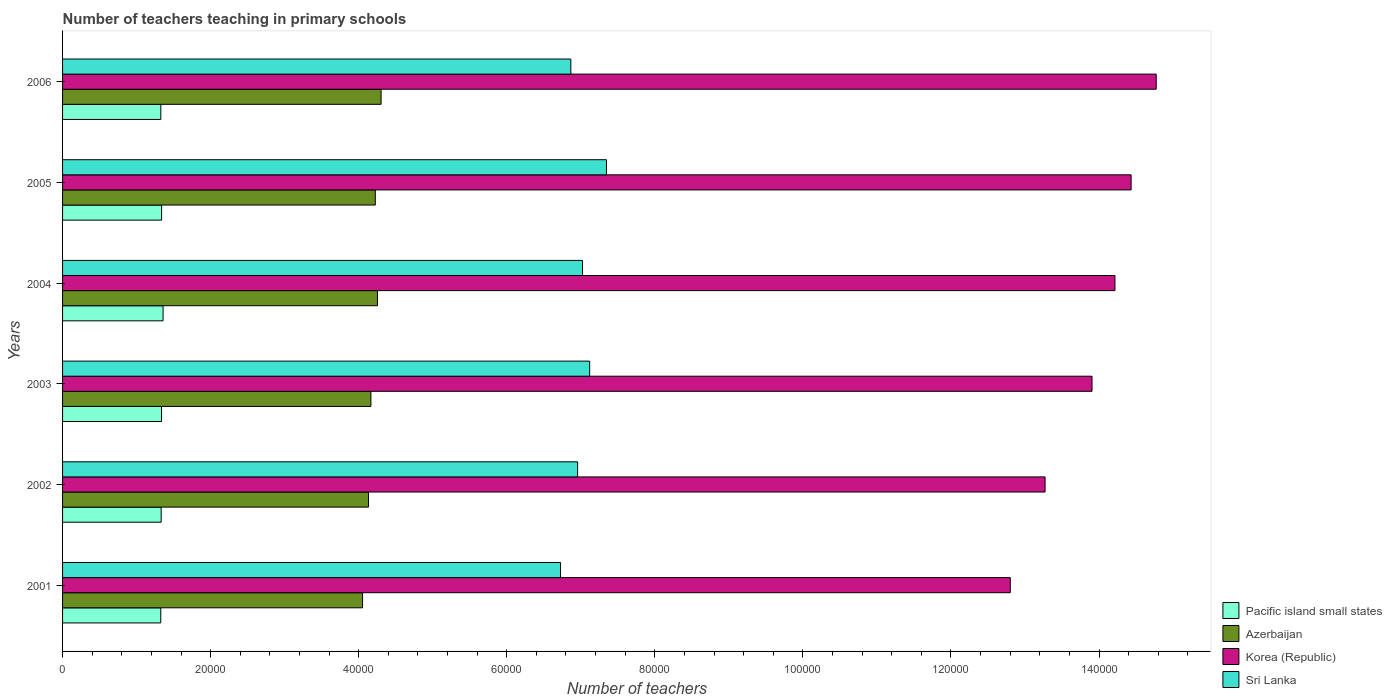Are the number of bars per tick equal to the number of legend labels?
Ensure brevity in your answer.  Yes. How many bars are there on the 1st tick from the top?
Ensure brevity in your answer.  4. What is the number of teachers teaching in primary schools in Korea (Republic) in 2002?
Ensure brevity in your answer.  1.33e+05. Across all years, what is the maximum number of teachers teaching in primary schools in Azerbaijan?
Provide a succinct answer. 4.30e+04. Across all years, what is the minimum number of teachers teaching in primary schools in Sri Lanka?
Offer a terse response. 6.73e+04. In which year was the number of teachers teaching in primary schools in Pacific island small states minimum?
Offer a very short reply. 2001. What is the total number of teachers teaching in primary schools in Pacific island small states in the graph?
Your answer should be compact. 8.02e+04. What is the difference between the number of teachers teaching in primary schools in Azerbaijan in 2005 and that in 2006?
Ensure brevity in your answer.  -783. What is the difference between the number of teachers teaching in primary schools in Pacific island small states in 2005 and the number of teachers teaching in primary schools in Azerbaijan in 2001?
Offer a terse response. -2.71e+04. What is the average number of teachers teaching in primary schools in Korea (Republic) per year?
Keep it short and to the point. 1.39e+05. In the year 2002, what is the difference between the number of teachers teaching in primary schools in Sri Lanka and number of teachers teaching in primary schools in Azerbaijan?
Your response must be concise. 2.82e+04. In how many years, is the number of teachers teaching in primary schools in Azerbaijan greater than 44000 ?
Your response must be concise. 0. What is the ratio of the number of teachers teaching in primary schools in Pacific island small states in 2001 to that in 2003?
Make the answer very short. 0.99. Is the difference between the number of teachers teaching in primary schools in Sri Lanka in 2003 and 2005 greater than the difference between the number of teachers teaching in primary schools in Azerbaijan in 2003 and 2005?
Give a very brief answer. No. What is the difference between the highest and the second highest number of teachers teaching in primary schools in Pacific island small states?
Give a very brief answer. 200.81. What is the difference between the highest and the lowest number of teachers teaching in primary schools in Pacific island small states?
Your response must be concise. 311.15. Is the sum of the number of teachers teaching in primary schools in Sri Lanka in 2002 and 2006 greater than the maximum number of teachers teaching in primary schools in Pacific island small states across all years?
Keep it short and to the point. Yes. Is it the case that in every year, the sum of the number of teachers teaching in primary schools in Korea (Republic) and number of teachers teaching in primary schools in Sri Lanka is greater than the sum of number of teachers teaching in primary schools in Pacific island small states and number of teachers teaching in primary schools in Azerbaijan?
Ensure brevity in your answer.  Yes. What does the 4th bar from the top in 2006 represents?
Give a very brief answer. Pacific island small states. What does the 2nd bar from the bottom in 2005 represents?
Offer a terse response. Azerbaijan. Is it the case that in every year, the sum of the number of teachers teaching in primary schools in Azerbaijan and number of teachers teaching in primary schools in Pacific island small states is greater than the number of teachers teaching in primary schools in Korea (Republic)?
Offer a terse response. No. Are all the bars in the graph horizontal?
Ensure brevity in your answer.  Yes. Are the values on the major ticks of X-axis written in scientific E-notation?
Provide a succinct answer. No. Where does the legend appear in the graph?
Your response must be concise. Bottom right. How many legend labels are there?
Provide a succinct answer. 4. What is the title of the graph?
Give a very brief answer. Number of teachers teaching in primary schools. What is the label or title of the X-axis?
Keep it short and to the point. Number of teachers. What is the label or title of the Y-axis?
Offer a terse response. Years. What is the Number of teachers of Pacific island small states in 2001?
Offer a terse response. 1.33e+04. What is the Number of teachers of Azerbaijan in 2001?
Your answer should be very brief. 4.05e+04. What is the Number of teachers of Korea (Republic) in 2001?
Offer a very short reply. 1.28e+05. What is the Number of teachers of Sri Lanka in 2001?
Offer a terse response. 6.73e+04. What is the Number of teachers in Pacific island small states in 2002?
Your answer should be very brief. 1.33e+04. What is the Number of teachers of Azerbaijan in 2002?
Make the answer very short. 4.13e+04. What is the Number of teachers in Korea (Republic) in 2002?
Offer a terse response. 1.33e+05. What is the Number of teachers of Sri Lanka in 2002?
Offer a very short reply. 6.96e+04. What is the Number of teachers in Pacific island small states in 2003?
Your response must be concise. 1.34e+04. What is the Number of teachers in Azerbaijan in 2003?
Keep it short and to the point. 4.17e+04. What is the Number of teachers in Korea (Republic) in 2003?
Your answer should be compact. 1.39e+05. What is the Number of teachers of Sri Lanka in 2003?
Your answer should be compact. 7.12e+04. What is the Number of teachers of Pacific island small states in 2004?
Your response must be concise. 1.36e+04. What is the Number of teachers of Azerbaijan in 2004?
Your answer should be very brief. 4.25e+04. What is the Number of teachers in Korea (Republic) in 2004?
Give a very brief answer. 1.42e+05. What is the Number of teachers of Sri Lanka in 2004?
Ensure brevity in your answer.  7.02e+04. What is the Number of teachers in Pacific island small states in 2005?
Offer a terse response. 1.34e+04. What is the Number of teachers of Azerbaijan in 2005?
Give a very brief answer. 4.22e+04. What is the Number of teachers in Korea (Republic) in 2005?
Your answer should be very brief. 1.44e+05. What is the Number of teachers in Sri Lanka in 2005?
Your answer should be very brief. 7.35e+04. What is the Number of teachers in Pacific island small states in 2006?
Your answer should be very brief. 1.33e+04. What is the Number of teachers of Azerbaijan in 2006?
Keep it short and to the point. 4.30e+04. What is the Number of teachers in Korea (Republic) in 2006?
Make the answer very short. 1.48e+05. What is the Number of teachers of Sri Lanka in 2006?
Give a very brief answer. 6.87e+04. Across all years, what is the maximum Number of teachers in Pacific island small states?
Your response must be concise. 1.36e+04. Across all years, what is the maximum Number of teachers in Azerbaijan?
Give a very brief answer. 4.30e+04. Across all years, what is the maximum Number of teachers in Korea (Republic)?
Your answer should be very brief. 1.48e+05. Across all years, what is the maximum Number of teachers of Sri Lanka?
Your answer should be very brief. 7.35e+04. Across all years, what is the minimum Number of teachers of Pacific island small states?
Offer a very short reply. 1.33e+04. Across all years, what is the minimum Number of teachers in Azerbaijan?
Make the answer very short. 4.05e+04. Across all years, what is the minimum Number of teachers in Korea (Republic)?
Offer a very short reply. 1.28e+05. Across all years, what is the minimum Number of teachers of Sri Lanka?
Your answer should be very brief. 6.73e+04. What is the total Number of teachers of Pacific island small states in the graph?
Ensure brevity in your answer.  8.02e+04. What is the total Number of teachers in Azerbaijan in the graph?
Ensure brevity in your answer.  2.51e+05. What is the total Number of teachers of Korea (Republic) in the graph?
Give a very brief answer. 8.34e+05. What is the total Number of teachers of Sri Lanka in the graph?
Provide a short and direct response. 4.20e+05. What is the difference between the Number of teachers of Pacific island small states in 2001 and that in 2002?
Give a very brief answer. -54.1. What is the difference between the Number of teachers in Azerbaijan in 2001 and that in 2002?
Your answer should be compact. -805. What is the difference between the Number of teachers in Korea (Republic) in 2001 and that in 2002?
Make the answer very short. -4698. What is the difference between the Number of teachers in Sri Lanka in 2001 and that in 2002?
Provide a succinct answer. -2305. What is the difference between the Number of teachers of Pacific island small states in 2001 and that in 2003?
Your answer should be compact. -102.72. What is the difference between the Number of teachers in Azerbaijan in 2001 and that in 2003?
Offer a very short reply. -1128. What is the difference between the Number of teachers in Korea (Republic) in 2001 and that in 2003?
Your answer should be very brief. -1.10e+04. What is the difference between the Number of teachers of Sri Lanka in 2001 and that in 2003?
Offer a very short reply. -3936. What is the difference between the Number of teachers of Pacific island small states in 2001 and that in 2004?
Offer a very short reply. -311.15. What is the difference between the Number of teachers in Azerbaijan in 2001 and that in 2004?
Your response must be concise. -2010. What is the difference between the Number of teachers of Korea (Republic) in 2001 and that in 2004?
Provide a short and direct response. -1.41e+04. What is the difference between the Number of teachers of Sri Lanka in 2001 and that in 2004?
Keep it short and to the point. -2971. What is the difference between the Number of teachers of Pacific island small states in 2001 and that in 2005?
Your response must be concise. -110.34. What is the difference between the Number of teachers of Azerbaijan in 2001 and that in 2005?
Your response must be concise. -1720. What is the difference between the Number of teachers in Korea (Republic) in 2001 and that in 2005?
Provide a succinct answer. -1.63e+04. What is the difference between the Number of teachers of Sri Lanka in 2001 and that in 2005?
Provide a short and direct response. -6206. What is the difference between the Number of teachers of Pacific island small states in 2001 and that in 2006?
Your answer should be compact. -6.57. What is the difference between the Number of teachers in Azerbaijan in 2001 and that in 2006?
Your response must be concise. -2503. What is the difference between the Number of teachers of Korea (Republic) in 2001 and that in 2006?
Ensure brevity in your answer.  -1.97e+04. What is the difference between the Number of teachers of Sri Lanka in 2001 and that in 2006?
Offer a very short reply. -1392. What is the difference between the Number of teachers in Pacific island small states in 2002 and that in 2003?
Provide a succinct answer. -48.62. What is the difference between the Number of teachers of Azerbaijan in 2002 and that in 2003?
Keep it short and to the point. -323. What is the difference between the Number of teachers in Korea (Republic) in 2002 and that in 2003?
Offer a terse response. -6341. What is the difference between the Number of teachers of Sri Lanka in 2002 and that in 2003?
Your answer should be very brief. -1631. What is the difference between the Number of teachers in Pacific island small states in 2002 and that in 2004?
Give a very brief answer. -257.05. What is the difference between the Number of teachers of Azerbaijan in 2002 and that in 2004?
Keep it short and to the point. -1205. What is the difference between the Number of teachers of Korea (Republic) in 2002 and that in 2004?
Offer a terse response. -9437. What is the difference between the Number of teachers in Sri Lanka in 2002 and that in 2004?
Your answer should be compact. -666. What is the difference between the Number of teachers in Pacific island small states in 2002 and that in 2005?
Your answer should be compact. -56.23. What is the difference between the Number of teachers of Azerbaijan in 2002 and that in 2005?
Provide a succinct answer. -915. What is the difference between the Number of teachers in Korea (Republic) in 2002 and that in 2005?
Provide a succinct answer. -1.16e+04. What is the difference between the Number of teachers in Sri Lanka in 2002 and that in 2005?
Offer a terse response. -3901. What is the difference between the Number of teachers in Pacific island small states in 2002 and that in 2006?
Make the answer very short. 47.54. What is the difference between the Number of teachers of Azerbaijan in 2002 and that in 2006?
Offer a very short reply. -1698. What is the difference between the Number of teachers in Korea (Republic) in 2002 and that in 2006?
Offer a very short reply. -1.50e+04. What is the difference between the Number of teachers of Sri Lanka in 2002 and that in 2006?
Keep it short and to the point. 913. What is the difference between the Number of teachers in Pacific island small states in 2003 and that in 2004?
Your response must be concise. -208.43. What is the difference between the Number of teachers in Azerbaijan in 2003 and that in 2004?
Offer a very short reply. -882. What is the difference between the Number of teachers of Korea (Republic) in 2003 and that in 2004?
Provide a short and direct response. -3096. What is the difference between the Number of teachers of Sri Lanka in 2003 and that in 2004?
Your answer should be compact. 965. What is the difference between the Number of teachers in Pacific island small states in 2003 and that in 2005?
Make the answer very short. -7.62. What is the difference between the Number of teachers in Azerbaijan in 2003 and that in 2005?
Give a very brief answer. -592. What is the difference between the Number of teachers of Korea (Republic) in 2003 and that in 2005?
Keep it short and to the point. -5281. What is the difference between the Number of teachers in Sri Lanka in 2003 and that in 2005?
Make the answer very short. -2270. What is the difference between the Number of teachers of Pacific island small states in 2003 and that in 2006?
Give a very brief answer. 96.15. What is the difference between the Number of teachers of Azerbaijan in 2003 and that in 2006?
Ensure brevity in your answer.  -1375. What is the difference between the Number of teachers in Korea (Republic) in 2003 and that in 2006?
Provide a succinct answer. -8671. What is the difference between the Number of teachers in Sri Lanka in 2003 and that in 2006?
Your response must be concise. 2544. What is the difference between the Number of teachers in Pacific island small states in 2004 and that in 2005?
Give a very brief answer. 200.81. What is the difference between the Number of teachers in Azerbaijan in 2004 and that in 2005?
Your response must be concise. 290. What is the difference between the Number of teachers of Korea (Republic) in 2004 and that in 2005?
Ensure brevity in your answer.  -2185. What is the difference between the Number of teachers of Sri Lanka in 2004 and that in 2005?
Offer a very short reply. -3235. What is the difference between the Number of teachers of Pacific island small states in 2004 and that in 2006?
Give a very brief answer. 304.58. What is the difference between the Number of teachers of Azerbaijan in 2004 and that in 2006?
Ensure brevity in your answer.  -493. What is the difference between the Number of teachers of Korea (Republic) in 2004 and that in 2006?
Give a very brief answer. -5575. What is the difference between the Number of teachers in Sri Lanka in 2004 and that in 2006?
Your answer should be very brief. 1579. What is the difference between the Number of teachers of Pacific island small states in 2005 and that in 2006?
Provide a succinct answer. 103.77. What is the difference between the Number of teachers of Azerbaijan in 2005 and that in 2006?
Your answer should be compact. -783. What is the difference between the Number of teachers of Korea (Republic) in 2005 and that in 2006?
Provide a succinct answer. -3390. What is the difference between the Number of teachers in Sri Lanka in 2005 and that in 2006?
Provide a succinct answer. 4814. What is the difference between the Number of teachers in Pacific island small states in 2001 and the Number of teachers in Azerbaijan in 2002?
Make the answer very short. -2.81e+04. What is the difference between the Number of teachers in Pacific island small states in 2001 and the Number of teachers in Korea (Republic) in 2002?
Your answer should be compact. -1.19e+05. What is the difference between the Number of teachers of Pacific island small states in 2001 and the Number of teachers of Sri Lanka in 2002?
Offer a terse response. -5.63e+04. What is the difference between the Number of teachers of Azerbaijan in 2001 and the Number of teachers of Korea (Republic) in 2002?
Provide a short and direct response. -9.22e+04. What is the difference between the Number of teachers of Azerbaijan in 2001 and the Number of teachers of Sri Lanka in 2002?
Your response must be concise. -2.90e+04. What is the difference between the Number of teachers of Korea (Republic) in 2001 and the Number of teachers of Sri Lanka in 2002?
Your response must be concise. 5.84e+04. What is the difference between the Number of teachers in Pacific island small states in 2001 and the Number of teachers in Azerbaijan in 2003?
Ensure brevity in your answer.  -2.84e+04. What is the difference between the Number of teachers of Pacific island small states in 2001 and the Number of teachers of Korea (Republic) in 2003?
Ensure brevity in your answer.  -1.26e+05. What is the difference between the Number of teachers of Pacific island small states in 2001 and the Number of teachers of Sri Lanka in 2003?
Keep it short and to the point. -5.79e+04. What is the difference between the Number of teachers of Azerbaijan in 2001 and the Number of teachers of Korea (Republic) in 2003?
Your answer should be very brief. -9.85e+04. What is the difference between the Number of teachers in Azerbaijan in 2001 and the Number of teachers in Sri Lanka in 2003?
Provide a short and direct response. -3.07e+04. What is the difference between the Number of teachers in Korea (Republic) in 2001 and the Number of teachers in Sri Lanka in 2003?
Offer a terse response. 5.68e+04. What is the difference between the Number of teachers of Pacific island small states in 2001 and the Number of teachers of Azerbaijan in 2004?
Keep it short and to the point. -2.93e+04. What is the difference between the Number of teachers of Pacific island small states in 2001 and the Number of teachers of Korea (Republic) in 2004?
Your answer should be compact. -1.29e+05. What is the difference between the Number of teachers of Pacific island small states in 2001 and the Number of teachers of Sri Lanka in 2004?
Provide a succinct answer. -5.70e+04. What is the difference between the Number of teachers of Azerbaijan in 2001 and the Number of teachers of Korea (Republic) in 2004?
Give a very brief answer. -1.02e+05. What is the difference between the Number of teachers in Azerbaijan in 2001 and the Number of teachers in Sri Lanka in 2004?
Offer a terse response. -2.97e+04. What is the difference between the Number of teachers of Korea (Republic) in 2001 and the Number of teachers of Sri Lanka in 2004?
Keep it short and to the point. 5.78e+04. What is the difference between the Number of teachers in Pacific island small states in 2001 and the Number of teachers in Azerbaijan in 2005?
Provide a short and direct response. -2.90e+04. What is the difference between the Number of teachers in Pacific island small states in 2001 and the Number of teachers in Korea (Republic) in 2005?
Provide a succinct answer. -1.31e+05. What is the difference between the Number of teachers of Pacific island small states in 2001 and the Number of teachers of Sri Lanka in 2005?
Make the answer very short. -6.02e+04. What is the difference between the Number of teachers of Azerbaijan in 2001 and the Number of teachers of Korea (Republic) in 2005?
Give a very brief answer. -1.04e+05. What is the difference between the Number of teachers of Azerbaijan in 2001 and the Number of teachers of Sri Lanka in 2005?
Provide a succinct answer. -3.29e+04. What is the difference between the Number of teachers of Korea (Republic) in 2001 and the Number of teachers of Sri Lanka in 2005?
Provide a succinct answer. 5.45e+04. What is the difference between the Number of teachers in Pacific island small states in 2001 and the Number of teachers in Azerbaijan in 2006?
Provide a succinct answer. -2.98e+04. What is the difference between the Number of teachers in Pacific island small states in 2001 and the Number of teachers in Korea (Republic) in 2006?
Give a very brief answer. -1.34e+05. What is the difference between the Number of teachers of Pacific island small states in 2001 and the Number of teachers of Sri Lanka in 2006?
Your answer should be compact. -5.54e+04. What is the difference between the Number of teachers in Azerbaijan in 2001 and the Number of teachers in Korea (Republic) in 2006?
Provide a succinct answer. -1.07e+05. What is the difference between the Number of teachers of Azerbaijan in 2001 and the Number of teachers of Sri Lanka in 2006?
Offer a very short reply. -2.81e+04. What is the difference between the Number of teachers of Korea (Republic) in 2001 and the Number of teachers of Sri Lanka in 2006?
Your answer should be very brief. 5.94e+04. What is the difference between the Number of teachers of Pacific island small states in 2002 and the Number of teachers of Azerbaijan in 2003?
Provide a succinct answer. -2.83e+04. What is the difference between the Number of teachers in Pacific island small states in 2002 and the Number of teachers in Korea (Republic) in 2003?
Give a very brief answer. -1.26e+05. What is the difference between the Number of teachers in Pacific island small states in 2002 and the Number of teachers in Sri Lanka in 2003?
Provide a short and direct response. -5.79e+04. What is the difference between the Number of teachers in Azerbaijan in 2002 and the Number of teachers in Korea (Republic) in 2003?
Your answer should be very brief. -9.77e+04. What is the difference between the Number of teachers in Azerbaijan in 2002 and the Number of teachers in Sri Lanka in 2003?
Offer a terse response. -2.99e+04. What is the difference between the Number of teachers of Korea (Republic) in 2002 and the Number of teachers of Sri Lanka in 2003?
Your answer should be compact. 6.15e+04. What is the difference between the Number of teachers of Pacific island small states in 2002 and the Number of teachers of Azerbaijan in 2004?
Provide a short and direct response. -2.92e+04. What is the difference between the Number of teachers of Pacific island small states in 2002 and the Number of teachers of Korea (Republic) in 2004?
Give a very brief answer. -1.29e+05. What is the difference between the Number of teachers in Pacific island small states in 2002 and the Number of teachers in Sri Lanka in 2004?
Offer a very short reply. -5.69e+04. What is the difference between the Number of teachers in Azerbaijan in 2002 and the Number of teachers in Korea (Republic) in 2004?
Offer a terse response. -1.01e+05. What is the difference between the Number of teachers in Azerbaijan in 2002 and the Number of teachers in Sri Lanka in 2004?
Your answer should be compact. -2.89e+04. What is the difference between the Number of teachers in Korea (Republic) in 2002 and the Number of teachers in Sri Lanka in 2004?
Your answer should be very brief. 6.25e+04. What is the difference between the Number of teachers of Pacific island small states in 2002 and the Number of teachers of Azerbaijan in 2005?
Your answer should be compact. -2.89e+04. What is the difference between the Number of teachers in Pacific island small states in 2002 and the Number of teachers in Korea (Republic) in 2005?
Ensure brevity in your answer.  -1.31e+05. What is the difference between the Number of teachers in Pacific island small states in 2002 and the Number of teachers in Sri Lanka in 2005?
Keep it short and to the point. -6.02e+04. What is the difference between the Number of teachers of Azerbaijan in 2002 and the Number of teachers of Korea (Republic) in 2005?
Make the answer very short. -1.03e+05. What is the difference between the Number of teachers in Azerbaijan in 2002 and the Number of teachers in Sri Lanka in 2005?
Offer a terse response. -3.21e+04. What is the difference between the Number of teachers of Korea (Republic) in 2002 and the Number of teachers of Sri Lanka in 2005?
Provide a short and direct response. 5.92e+04. What is the difference between the Number of teachers in Pacific island small states in 2002 and the Number of teachers in Azerbaijan in 2006?
Offer a terse response. -2.97e+04. What is the difference between the Number of teachers of Pacific island small states in 2002 and the Number of teachers of Korea (Republic) in 2006?
Ensure brevity in your answer.  -1.34e+05. What is the difference between the Number of teachers in Pacific island small states in 2002 and the Number of teachers in Sri Lanka in 2006?
Your answer should be very brief. -5.53e+04. What is the difference between the Number of teachers in Azerbaijan in 2002 and the Number of teachers in Korea (Republic) in 2006?
Your response must be concise. -1.06e+05. What is the difference between the Number of teachers of Azerbaijan in 2002 and the Number of teachers of Sri Lanka in 2006?
Keep it short and to the point. -2.73e+04. What is the difference between the Number of teachers in Korea (Republic) in 2002 and the Number of teachers in Sri Lanka in 2006?
Ensure brevity in your answer.  6.41e+04. What is the difference between the Number of teachers in Pacific island small states in 2003 and the Number of teachers in Azerbaijan in 2004?
Provide a short and direct response. -2.92e+04. What is the difference between the Number of teachers of Pacific island small states in 2003 and the Number of teachers of Korea (Republic) in 2004?
Your response must be concise. -1.29e+05. What is the difference between the Number of teachers in Pacific island small states in 2003 and the Number of teachers in Sri Lanka in 2004?
Provide a short and direct response. -5.69e+04. What is the difference between the Number of teachers in Azerbaijan in 2003 and the Number of teachers in Korea (Republic) in 2004?
Offer a very short reply. -1.01e+05. What is the difference between the Number of teachers in Azerbaijan in 2003 and the Number of teachers in Sri Lanka in 2004?
Your answer should be very brief. -2.86e+04. What is the difference between the Number of teachers of Korea (Republic) in 2003 and the Number of teachers of Sri Lanka in 2004?
Your answer should be very brief. 6.88e+04. What is the difference between the Number of teachers in Pacific island small states in 2003 and the Number of teachers in Azerbaijan in 2005?
Make the answer very short. -2.89e+04. What is the difference between the Number of teachers of Pacific island small states in 2003 and the Number of teachers of Korea (Republic) in 2005?
Your answer should be very brief. -1.31e+05. What is the difference between the Number of teachers in Pacific island small states in 2003 and the Number of teachers in Sri Lanka in 2005?
Provide a short and direct response. -6.01e+04. What is the difference between the Number of teachers of Azerbaijan in 2003 and the Number of teachers of Korea (Republic) in 2005?
Give a very brief answer. -1.03e+05. What is the difference between the Number of teachers in Azerbaijan in 2003 and the Number of teachers in Sri Lanka in 2005?
Offer a terse response. -3.18e+04. What is the difference between the Number of teachers in Korea (Republic) in 2003 and the Number of teachers in Sri Lanka in 2005?
Provide a succinct answer. 6.56e+04. What is the difference between the Number of teachers in Pacific island small states in 2003 and the Number of teachers in Azerbaijan in 2006?
Give a very brief answer. -2.97e+04. What is the difference between the Number of teachers in Pacific island small states in 2003 and the Number of teachers in Korea (Republic) in 2006?
Provide a short and direct response. -1.34e+05. What is the difference between the Number of teachers in Pacific island small states in 2003 and the Number of teachers in Sri Lanka in 2006?
Provide a short and direct response. -5.53e+04. What is the difference between the Number of teachers in Azerbaijan in 2003 and the Number of teachers in Korea (Republic) in 2006?
Offer a very short reply. -1.06e+05. What is the difference between the Number of teachers of Azerbaijan in 2003 and the Number of teachers of Sri Lanka in 2006?
Your answer should be very brief. -2.70e+04. What is the difference between the Number of teachers in Korea (Republic) in 2003 and the Number of teachers in Sri Lanka in 2006?
Provide a short and direct response. 7.04e+04. What is the difference between the Number of teachers of Pacific island small states in 2004 and the Number of teachers of Azerbaijan in 2005?
Make the answer very short. -2.87e+04. What is the difference between the Number of teachers in Pacific island small states in 2004 and the Number of teachers in Korea (Republic) in 2005?
Make the answer very short. -1.31e+05. What is the difference between the Number of teachers of Pacific island small states in 2004 and the Number of teachers of Sri Lanka in 2005?
Provide a succinct answer. -5.99e+04. What is the difference between the Number of teachers of Azerbaijan in 2004 and the Number of teachers of Korea (Republic) in 2005?
Your response must be concise. -1.02e+05. What is the difference between the Number of teachers of Azerbaijan in 2004 and the Number of teachers of Sri Lanka in 2005?
Make the answer very short. -3.09e+04. What is the difference between the Number of teachers in Korea (Republic) in 2004 and the Number of teachers in Sri Lanka in 2005?
Your response must be concise. 6.87e+04. What is the difference between the Number of teachers in Pacific island small states in 2004 and the Number of teachers in Azerbaijan in 2006?
Provide a short and direct response. -2.94e+04. What is the difference between the Number of teachers of Pacific island small states in 2004 and the Number of teachers of Korea (Republic) in 2006?
Make the answer very short. -1.34e+05. What is the difference between the Number of teachers of Pacific island small states in 2004 and the Number of teachers of Sri Lanka in 2006?
Your answer should be compact. -5.51e+04. What is the difference between the Number of teachers in Azerbaijan in 2004 and the Number of teachers in Korea (Republic) in 2006?
Your answer should be very brief. -1.05e+05. What is the difference between the Number of teachers in Azerbaijan in 2004 and the Number of teachers in Sri Lanka in 2006?
Make the answer very short. -2.61e+04. What is the difference between the Number of teachers in Korea (Republic) in 2004 and the Number of teachers in Sri Lanka in 2006?
Ensure brevity in your answer.  7.35e+04. What is the difference between the Number of teachers in Pacific island small states in 2005 and the Number of teachers in Azerbaijan in 2006?
Make the answer very short. -2.96e+04. What is the difference between the Number of teachers of Pacific island small states in 2005 and the Number of teachers of Korea (Republic) in 2006?
Keep it short and to the point. -1.34e+05. What is the difference between the Number of teachers of Pacific island small states in 2005 and the Number of teachers of Sri Lanka in 2006?
Your answer should be very brief. -5.53e+04. What is the difference between the Number of teachers of Azerbaijan in 2005 and the Number of teachers of Korea (Republic) in 2006?
Provide a succinct answer. -1.05e+05. What is the difference between the Number of teachers of Azerbaijan in 2005 and the Number of teachers of Sri Lanka in 2006?
Ensure brevity in your answer.  -2.64e+04. What is the difference between the Number of teachers in Korea (Republic) in 2005 and the Number of teachers in Sri Lanka in 2006?
Offer a very short reply. 7.57e+04. What is the average Number of teachers in Pacific island small states per year?
Ensure brevity in your answer.  1.34e+04. What is the average Number of teachers of Azerbaijan per year?
Offer a very short reply. 4.19e+04. What is the average Number of teachers of Korea (Republic) per year?
Provide a short and direct response. 1.39e+05. What is the average Number of teachers in Sri Lanka per year?
Offer a terse response. 7.01e+04. In the year 2001, what is the difference between the Number of teachers in Pacific island small states and Number of teachers in Azerbaijan?
Your answer should be compact. -2.73e+04. In the year 2001, what is the difference between the Number of teachers in Pacific island small states and Number of teachers in Korea (Republic)?
Offer a very short reply. -1.15e+05. In the year 2001, what is the difference between the Number of teachers of Pacific island small states and Number of teachers of Sri Lanka?
Make the answer very short. -5.40e+04. In the year 2001, what is the difference between the Number of teachers in Azerbaijan and Number of teachers in Korea (Republic)?
Give a very brief answer. -8.75e+04. In the year 2001, what is the difference between the Number of teachers of Azerbaijan and Number of teachers of Sri Lanka?
Your answer should be very brief. -2.67e+04. In the year 2001, what is the difference between the Number of teachers of Korea (Republic) and Number of teachers of Sri Lanka?
Give a very brief answer. 6.08e+04. In the year 2002, what is the difference between the Number of teachers in Pacific island small states and Number of teachers in Azerbaijan?
Make the answer very short. -2.80e+04. In the year 2002, what is the difference between the Number of teachers of Pacific island small states and Number of teachers of Korea (Republic)?
Ensure brevity in your answer.  -1.19e+05. In the year 2002, what is the difference between the Number of teachers of Pacific island small states and Number of teachers of Sri Lanka?
Keep it short and to the point. -5.63e+04. In the year 2002, what is the difference between the Number of teachers of Azerbaijan and Number of teachers of Korea (Republic)?
Offer a terse response. -9.14e+04. In the year 2002, what is the difference between the Number of teachers in Azerbaijan and Number of teachers in Sri Lanka?
Provide a succinct answer. -2.82e+04. In the year 2002, what is the difference between the Number of teachers in Korea (Republic) and Number of teachers in Sri Lanka?
Ensure brevity in your answer.  6.31e+04. In the year 2003, what is the difference between the Number of teachers in Pacific island small states and Number of teachers in Azerbaijan?
Give a very brief answer. -2.83e+04. In the year 2003, what is the difference between the Number of teachers of Pacific island small states and Number of teachers of Korea (Republic)?
Make the answer very short. -1.26e+05. In the year 2003, what is the difference between the Number of teachers of Pacific island small states and Number of teachers of Sri Lanka?
Give a very brief answer. -5.78e+04. In the year 2003, what is the difference between the Number of teachers in Azerbaijan and Number of teachers in Korea (Republic)?
Provide a succinct answer. -9.74e+04. In the year 2003, what is the difference between the Number of teachers of Azerbaijan and Number of teachers of Sri Lanka?
Your response must be concise. -2.96e+04. In the year 2003, what is the difference between the Number of teachers in Korea (Republic) and Number of teachers in Sri Lanka?
Provide a short and direct response. 6.79e+04. In the year 2004, what is the difference between the Number of teachers of Pacific island small states and Number of teachers of Azerbaijan?
Provide a succinct answer. -2.90e+04. In the year 2004, what is the difference between the Number of teachers in Pacific island small states and Number of teachers in Korea (Republic)?
Your response must be concise. -1.29e+05. In the year 2004, what is the difference between the Number of teachers of Pacific island small states and Number of teachers of Sri Lanka?
Provide a short and direct response. -5.67e+04. In the year 2004, what is the difference between the Number of teachers of Azerbaijan and Number of teachers of Korea (Republic)?
Offer a very short reply. -9.96e+04. In the year 2004, what is the difference between the Number of teachers in Azerbaijan and Number of teachers in Sri Lanka?
Keep it short and to the point. -2.77e+04. In the year 2004, what is the difference between the Number of teachers in Korea (Republic) and Number of teachers in Sri Lanka?
Give a very brief answer. 7.19e+04. In the year 2005, what is the difference between the Number of teachers in Pacific island small states and Number of teachers in Azerbaijan?
Give a very brief answer. -2.89e+04. In the year 2005, what is the difference between the Number of teachers of Pacific island small states and Number of teachers of Korea (Republic)?
Offer a terse response. -1.31e+05. In the year 2005, what is the difference between the Number of teachers of Pacific island small states and Number of teachers of Sri Lanka?
Keep it short and to the point. -6.01e+04. In the year 2005, what is the difference between the Number of teachers of Azerbaijan and Number of teachers of Korea (Republic)?
Keep it short and to the point. -1.02e+05. In the year 2005, what is the difference between the Number of teachers in Azerbaijan and Number of teachers in Sri Lanka?
Give a very brief answer. -3.12e+04. In the year 2005, what is the difference between the Number of teachers of Korea (Republic) and Number of teachers of Sri Lanka?
Provide a succinct answer. 7.09e+04. In the year 2006, what is the difference between the Number of teachers in Pacific island small states and Number of teachers in Azerbaijan?
Your answer should be very brief. -2.98e+04. In the year 2006, what is the difference between the Number of teachers in Pacific island small states and Number of teachers in Korea (Republic)?
Keep it short and to the point. -1.34e+05. In the year 2006, what is the difference between the Number of teachers in Pacific island small states and Number of teachers in Sri Lanka?
Your response must be concise. -5.54e+04. In the year 2006, what is the difference between the Number of teachers in Azerbaijan and Number of teachers in Korea (Republic)?
Your response must be concise. -1.05e+05. In the year 2006, what is the difference between the Number of teachers in Azerbaijan and Number of teachers in Sri Lanka?
Ensure brevity in your answer.  -2.56e+04. In the year 2006, what is the difference between the Number of teachers in Korea (Republic) and Number of teachers in Sri Lanka?
Offer a very short reply. 7.91e+04. What is the ratio of the Number of teachers in Pacific island small states in 2001 to that in 2002?
Keep it short and to the point. 1. What is the ratio of the Number of teachers of Azerbaijan in 2001 to that in 2002?
Give a very brief answer. 0.98. What is the ratio of the Number of teachers of Korea (Republic) in 2001 to that in 2002?
Your response must be concise. 0.96. What is the ratio of the Number of teachers of Sri Lanka in 2001 to that in 2002?
Provide a short and direct response. 0.97. What is the ratio of the Number of teachers in Azerbaijan in 2001 to that in 2003?
Ensure brevity in your answer.  0.97. What is the ratio of the Number of teachers of Korea (Republic) in 2001 to that in 2003?
Ensure brevity in your answer.  0.92. What is the ratio of the Number of teachers in Sri Lanka in 2001 to that in 2003?
Keep it short and to the point. 0.94. What is the ratio of the Number of teachers of Pacific island small states in 2001 to that in 2004?
Offer a very short reply. 0.98. What is the ratio of the Number of teachers of Azerbaijan in 2001 to that in 2004?
Your answer should be compact. 0.95. What is the ratio of the Number of teachers of Korea (Republic) in 2001 to that in 2004?
Your response must be concise. 0.9. What is the ratio of the Number of teachers in Sri Lanka in 2001 to that in 2004?
Keep it short and to the point. 0.96. What is the ratio of the Number of teachers of Azerbaijan in 2001 to that in 2005?
Make the answer very short. 0.96. What is the ratio of the Number of teachers of Korea (Republic) in 2001 to that in 2005?
Offer a very short reply. 0.89. What is the ratio of the Number of teachers of Sri Lanka in 2001 to that in 2005?
Your answer should be compact. 0.92. What is the ratio of the Number of teachers of Azerbaijan in 2001 to that in 2006?
Provide a short and direct response. 0.94. What is the ratio of the Number of teachers of Korea (Republic) in 2001 to that in 2006?
Keep it short and to the point. 0.87. What is the ratio of the Number of teachers of Sri Lanka in 2001 to that in 2006?
Your response must be concise. 0.98. What is the ratio of the Number of teachers in Pacific island small states in 2002 to that in 2003?
Make the answer very short. 1. What is the ratio of the Number of teachers in Azerbaijan in 2002 to that in 2003?
Offer a terse response. 0.99. What is the ratio of the Number of teachers in Korea (Republic) in 2002 to that in 2003?
Give a very brief answer. 0.95. What is the ratio of the Number of teachers of Sri Lanka in 2002 to that in 2003?
Offer a terse response. 0.98. What is the ratio of the Number of teachers of Pacific island small states in 2002 to that in 2004?
Provide a succinct answer. 0.98. What is the ratio of the Number of teachers of Azerbaijan in 2002 to that in 2004?
Your answer should be very brief. 0.97. What is the ratio of the Number of teachers in Korea (Republic) in 2002 to that in 2004?
Keep it short and to the point. 0.93. What is the ratio of the Number of teachers of Sri Lanka in 2002 to that in 2004?
Your answer should be compact. 0.99. What is the ratio of the Number of teachers of Azerbaijan in 2002 to that in 2005?
Provide a succinct answer. 0.98. What is the ratio of the Number of teachers of Korea (Republic) in 2002 to that in 2005?
Your answer should be compact. 0.92. What is the ratio of the Number of teachers of Sri Lanka in 2002 to that in 2005?
Give a very brief answer. 0.95. What is the ratio of the Number of teachers of Azerbaijan in 2002 to that in 2006?
Ensure brevity in your answer.  0.96. What is the ratio of the Number of teachers in Korea (Republic) in 2002 to that in 2006?
Provide a succinct answer. 0.9. What is the ratio of the Number of teachers in Sri Lanka in 2002 to that in 2006?
Offer a very short reply. 1.01. What is the ratio of the Number of teachers in Pacific island small states in 2003 to that in 2004?
Provide a succinct answer. 0.98. What is the ratio of the Number of teachers of Azerbaijan in 2003 to that in 2004?
Your response must be concise. 0.98. What is the ratio of the Number of teachers of Korea (Republic) in 2003 to that in 2004?
Provide a short and direct response. 0.98. What is the ratio of the Number of teachers of Sri Lanka in 2003 to that in 2004?
Your answer should be very brief. 1.01. What is the ratio of the Number of teachers in Korea (Republic) in 2003 to that in 2005?
Your answer should be very brief. 0.96. What is the ratio of the Number of teachers in Sri Lanka in 2003 to that in 2005?
Your answer should be very brief. 0.97. What is the ratio of the Number of teachers of Pacific island small states in 2003 to that in 2006?
Ensure brevity in your answer.  1.01. What is the ratio of the Number of teachers of Korea (Republic) in 2003 to that in 2006?
Make the answer very short. 0.94. What is the ratio of the Number of teachers of Sri Lanka in 2003 to that in 2006?
Provide a short and direct response. 1.04. What is the ratio of the Number of teachers in Pacific island small states in 2004 to that in 2005?
Ensure brevity in your answer.  1.01. What is the ratio of the Number of teachers in Azerbaijan in 2004 to that in 2005?
Keep it short and to the point. 1.01. What is the ratio of the Number of teachers in Korea (Republic) in 2004 to that in 2005?
Offer a terse response. 0.98. What is the ratio of the Number of teachers of Sri Lanka in 2004 to that in 2005?
Your answer should be very brief. 0.96. What is the ratio of the Number of teachers of Pacific island small states in 2004 to that in 2006?
Offer a terse response. 1.02. What is the ratio of the Number of teachers of Azerbaijan in 2004 to that in 2006?
Your answer should be very brief. 0.99. What is the ratio of the Number of teachers in Korea (Republic) in 2004 to that in 2006?
Your response must be concise. 0.96. What is the ratio of the Number of teachers in Sri Lanka in 2004 to that in 2006?
Give a very brief answer. 1.02. What is the ratio of the Number of teachers of Azerbaijan in 2005 to that in 2006?
Your answer should be very brief. 0.98. What is the ratio of the Number of teachers of Korea (Republic) in 2005 to that in 2006?
Your answer should be very brief. 0.98. What is the ratio of the Number of teachers of Sri Lanka in 2005 to that in 2006?
Give a very brief answer. 1.07. What is the difference between the highest and the second highest Number of teachers in Pacific island small states?
Your answer should be compact. 200.81. What is the difference between the highest and the second highest Number of teachers in Azerbaijan?
Provide a succinct answer. 493. What is the difference between the highest and the second highest Number of teachers of Korea (Republic)?
Make the answer very short. 3390. What is the difference between the highest and the second highest Number of teachers of Sri Lanka?
Give a very brief answer. 2270. What is the difference between the highest and the lowest Number of teachers in Pacific island small states?
Offer a terse response. 311.15. What is the difference between the highest and the lowest Number of teachers of Azerbaijan?
Provide a short and direct response. 2503. What is the difference between the highest and the lowest Number of teachers of Korea (Republic)?
Offer a terse response. 1.97e+04. What is the difference between the highest and the lowest Number of teachers in Sri Lanka?
Offer a very short reply. 6206. 